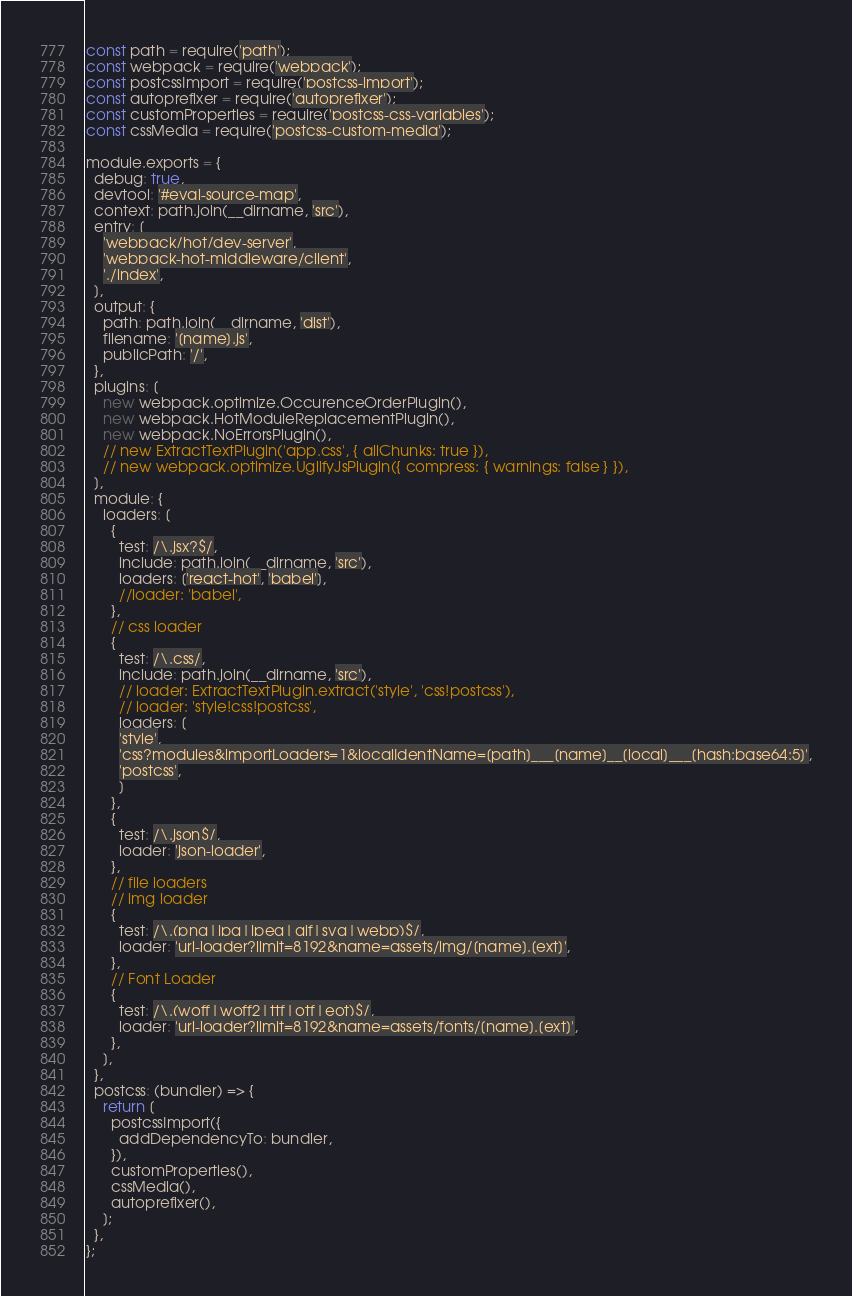<code> <loc_0><loc_0><loc_500><loc_500><_JavaScript_>const path = require('path');
const webpack = require('webpack');
const postcssImport = require('postcss-import');
const autoprefixer = require('autoprefixer');
const customProperties = require('postcss-css-variables');
const cssMedia = require('postcss-custom-media');

module.exports = {
  debug: true,
  devtool: '#eval-source-map',
  context: path.join(__dirname, 'src'),
  entry: [
    'webpack/hot/dev-server',
    'webpack-hot-middleware/client',
    './index',
  ],
  output: {
    path: path.join(__dirname, 'dist'),
    filename: '[name].js',
    publicPath: '/',
  },
  plugins: [
    new webpack.optimize.OccurenceOrderPlugin(),
    new webpack.HotModuleReplacementPlugin(),
    new webpack.NoErrorsPlugin(),
    // new ExtractTextPlugin('app.css', { allChunks: true }),
    // new webpack.optimize.UglifyJsPlugin({ compress: { warnings: false } }),
  ],
  module: {
    loaders: [
      {
        test: /\.jsx?$/,
        include: path.join(__dirname, 'src'),
        loaders: ['react-hot', 'babel'],
        //loader: 'babel',
      },
      // css loader
      {
        test: /\.css/,
        include: path.join(__dirname, 'src'),
        // loader: ExtractTextPlugin.extract('style', 'css!postcss'),
        // loader: 'style!css!postcss',
        loaders: [
        'style',
        'css?modules&importLoaders=1&localIdentName=[path]___[name]__[local]___[hash:base64:5]',
        'postcss',
        ]
      },
      {
        test: /\.json$/,
        loader: 'json-loader',
      },
      // file loaders
      // img loader
      {
        test: /\.(png|jpg|jpeg|gif|svg|webp)$/,
        loader: 'url-loader?limit=8192&name=assets/img/[name].[ext]',
      },
      // Font Loader
      {
        test: /\.(woff|woff2|ttf|otf|eot)$/,
        loader: 'url-loader?limit=8192&name=assets/fonts/[name].[ext]',
      },
    ],
  },
  postcss: (bundler) => {
    return [
      postcssImport({
        addDependencyTo: bundler,
      }),
      customProperties(),
      cssMedia(),
      autoprefixer(),
    ];
  },
};
</code> 